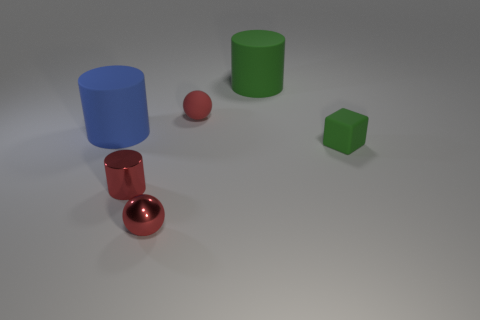Subtract all red spheres. How many were subtracted if there are1red spheres left? 1 Add 2 red shiny things. How many objects exist? 8 Subtract all spheres. How many objects are left? 4 Subtract 1 red cylinders. How many objects are left? 5 Subtract all large objects. Subtract all red matte objects. How many objects are left? 3 Add 2 small metallic things. How many small metallic things are left? 4 Add 2 tiny rubber objects. How many tiny rubber objects exist? 4 